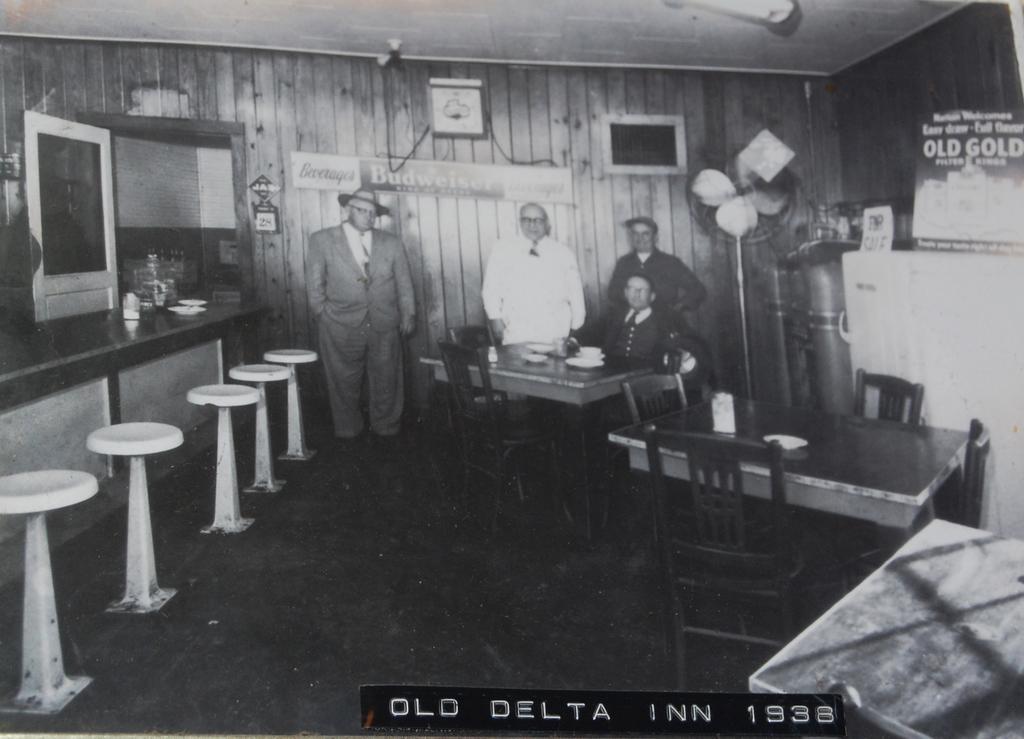How would you summarize this image in a sentence or two? This picture show few people standing and a man seated on the chair and we see few tools on the side and a photo frame on the wall 